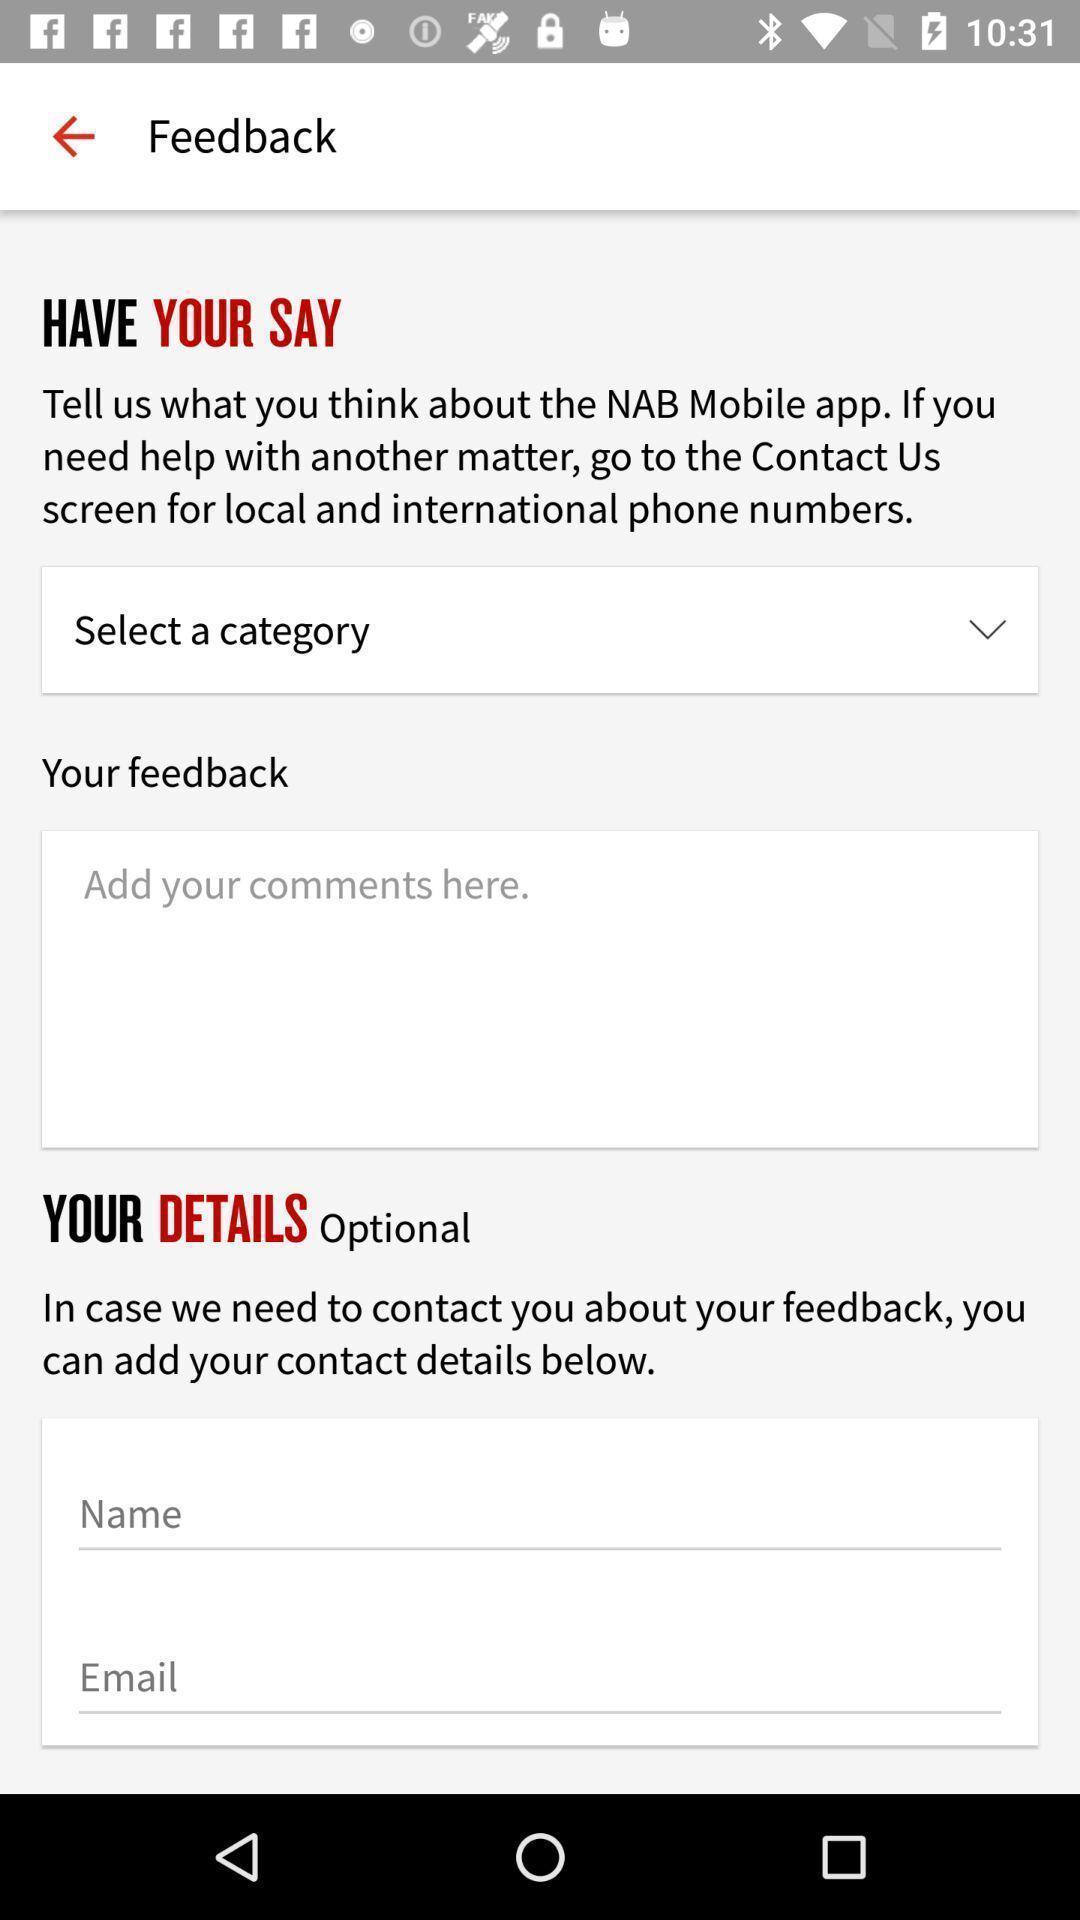Tell me about the visual elements in this screen capture. Page displaying to enter details in financial app. 